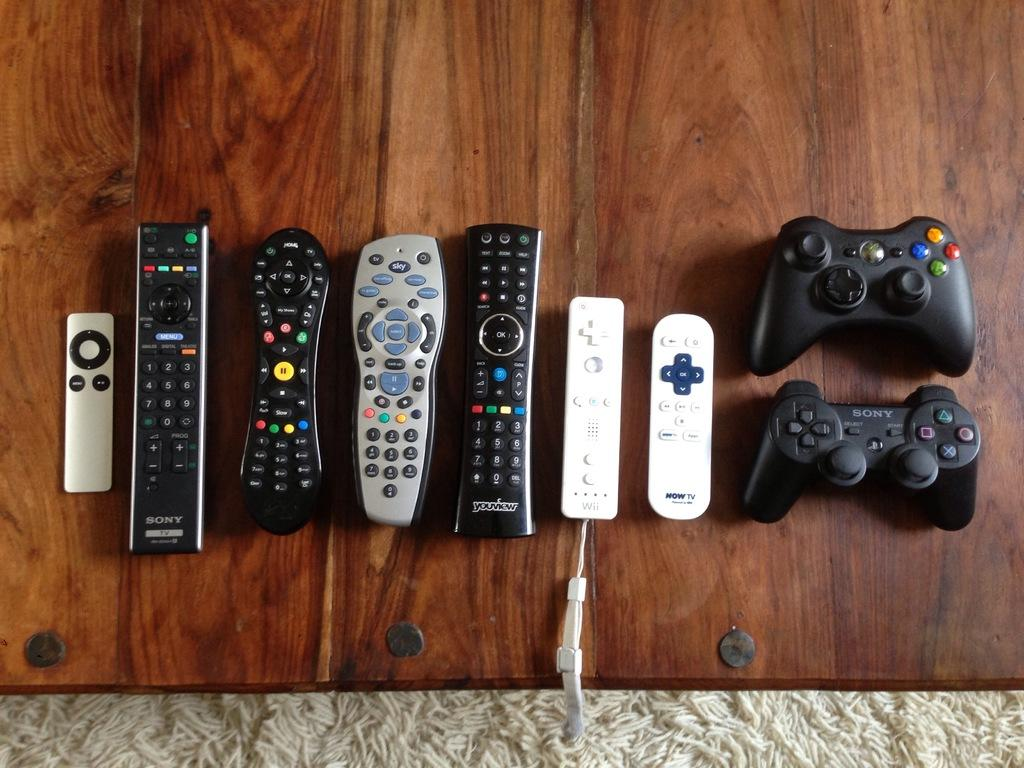Provide a one-sentence caption for the provided image. A bunch of remove control on the table, and two of them say Sony. 